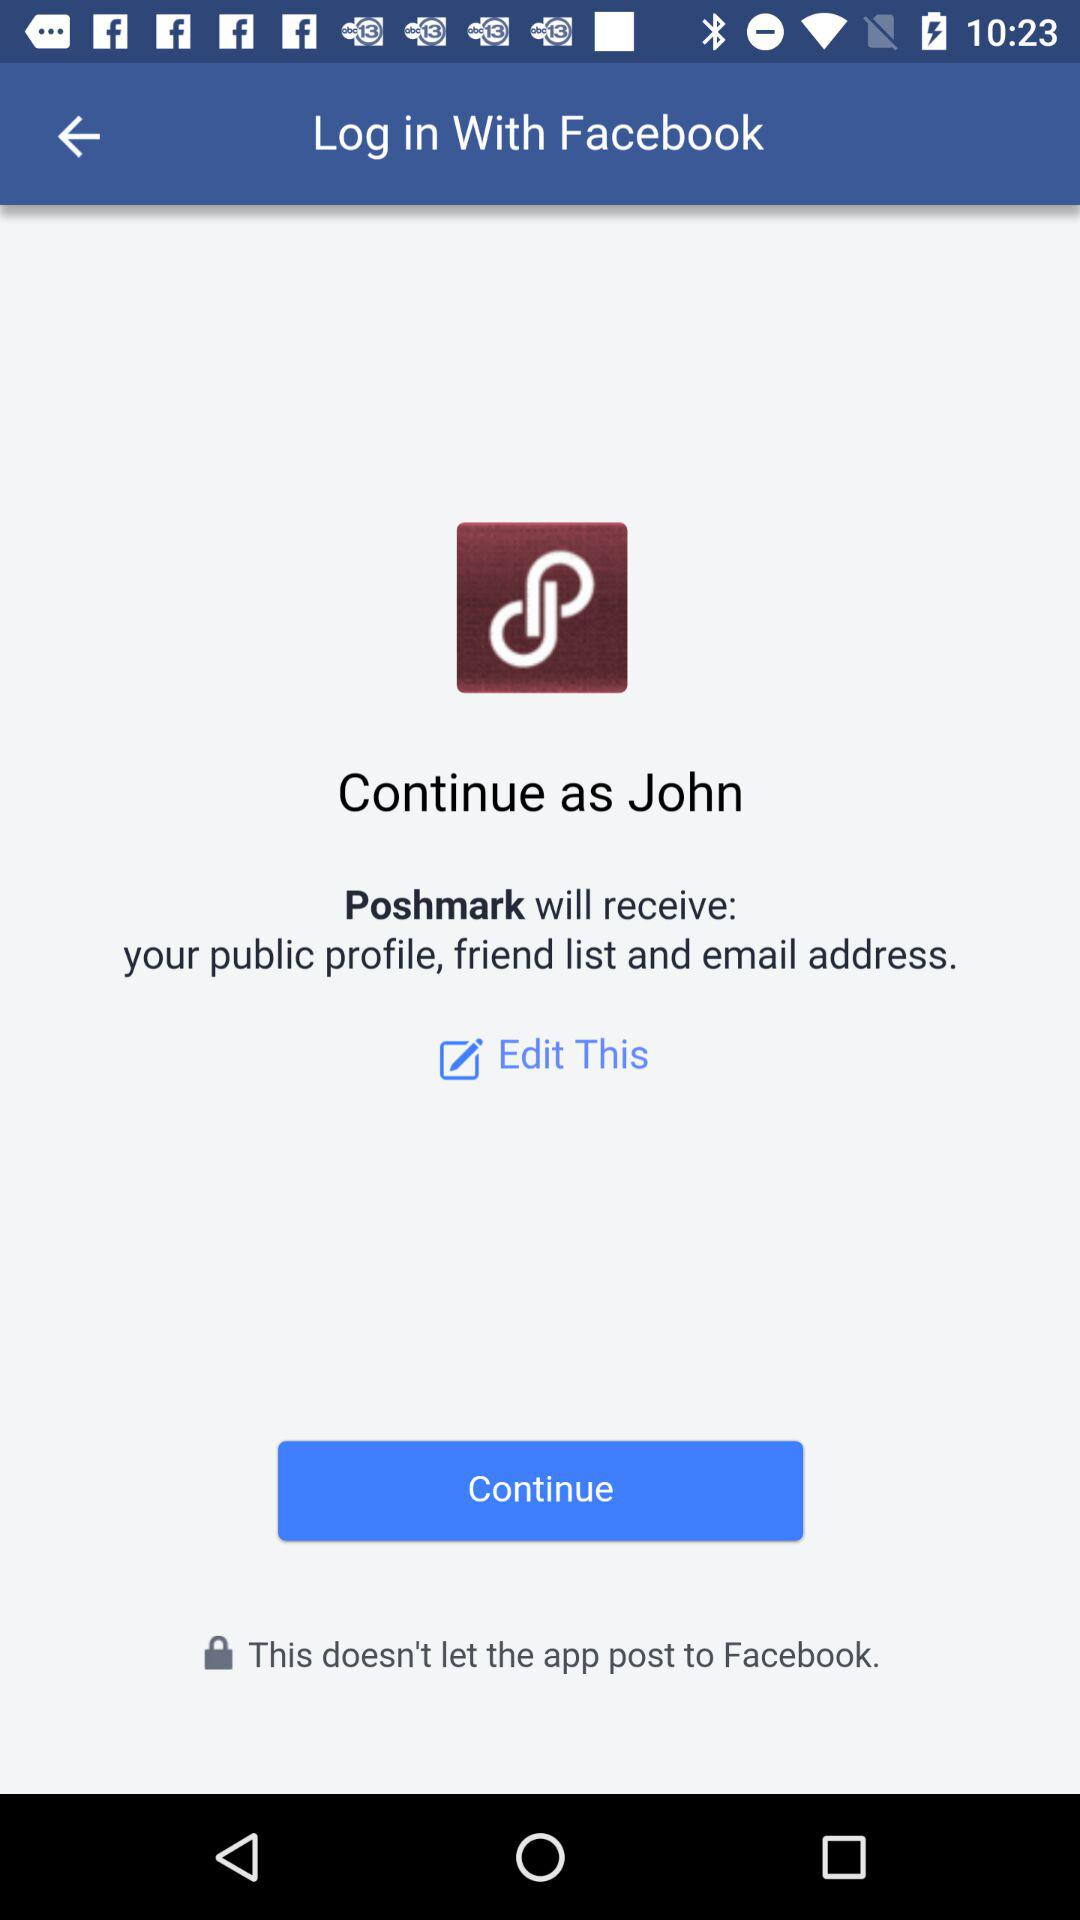What is the login name? The login name is John. 